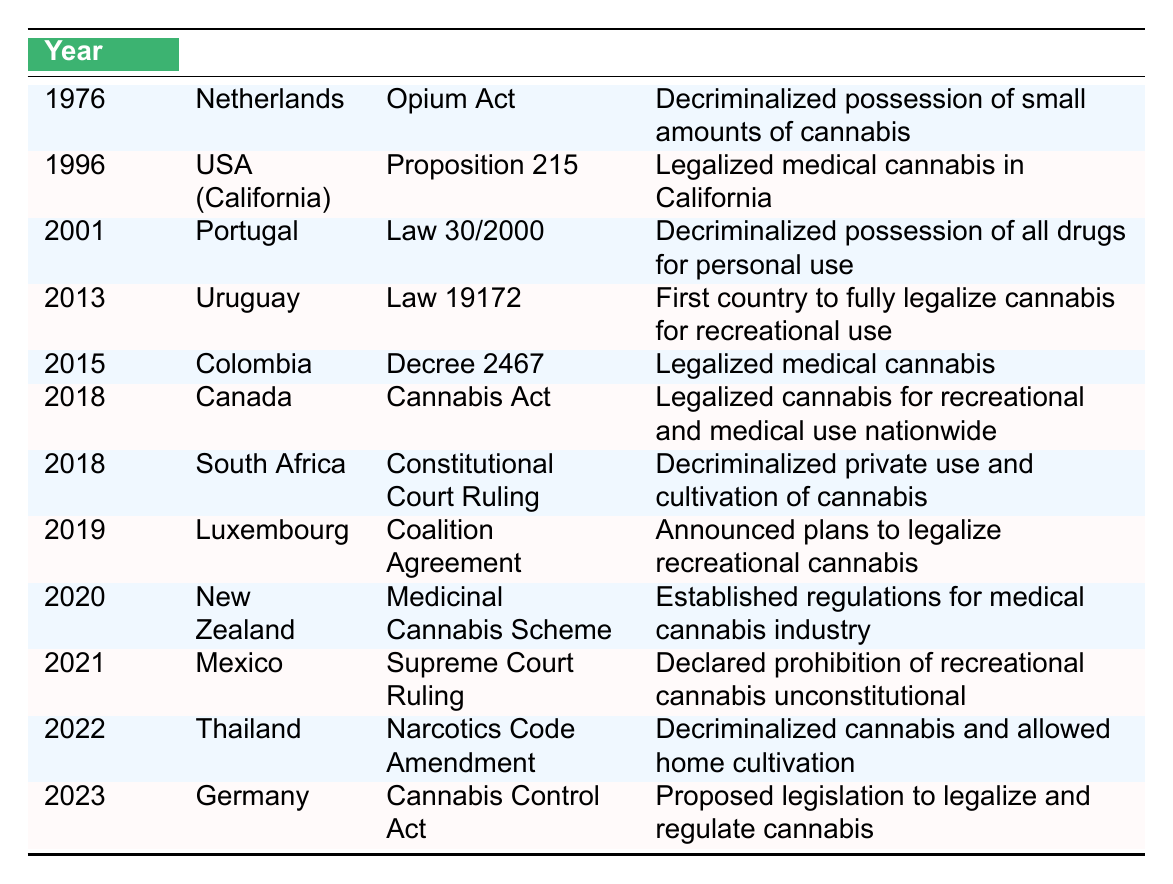What year did Canada legalize cannabis for recreational and medical use? According to the table, Canada legalized cannabis for recreational and medical use in the year 2018.
Answer: 2018 Which country was the first to fully legalize cannabis for recreational use? The table indicates that Uruguay was the first country to fully legalize cannabis for recreational use in 2013.
Answer: Uruguay How many countries decriminalized cannabis use before 2020? The table shows that the Netherlands in 1976, Portugal in 2001, South Africa in 2018, and Thailand in 2022 decriminalized cannabis, which is a total of 3 countries before 2020.
Answer: 3 Has Mexico declared the prohibition of recreational cannabis unconstitutional? Yes, the table states that Mexico's Supreme Court ruling in 2021 declared the prohibition of recreational cannabis unconstitutional, so the answer is yes.
Answer: Yes Which country passed legislation to establish regulations for the medical cannabis industry in 2020? The table reflects that New Zealand established regulations for the medical cannabis industry in 2020 through their Medicinal Cannabis Scheme.
Answer: New Zealand What is the difference in years between when the Netherlands decriminalized cannabis and when Canada legalized it? The Netherlands decriminalized cannabis in 1976 and Canada legalized it in 2018. The difference is 2018 - 1976 = 42 years.
Answer: 42 years Is the Cannabis Control Act proposed in Germany related to legalization or decriminalization? The table specifies that the Cannabis Control Act proposed in Germany is related to the legalization and regulation of cannabis, not just decriminalization.
Answer: Legalization Which countries legalized medical cannabis between 2015 and 2021? The table reveals that Colombia legalized medical cannabis in 2015 and Mexico declared the prohibition of recreational cannabis unconstitutional in 2021, but it does not specify legalization for medical from Mexico. Thus, the answer is Colombia.
Answer: Colombia How many years apart are the cannabis legislation changes in Uruguay and Germany? Uruguay legalized cannabis for recreational use in 2013, and Germany proposed the Cannabis Control Act in 2023. The difference is 2023 - 2013 = 10 years.
Answer: 10 years What type of legislation was passed in Luxembourg in 2019? The table indicates that Luxembourg had announced plans to legalize recreational cannabis in 2019 through a Coalition Agreement.
Answer: Coalition Agreement 